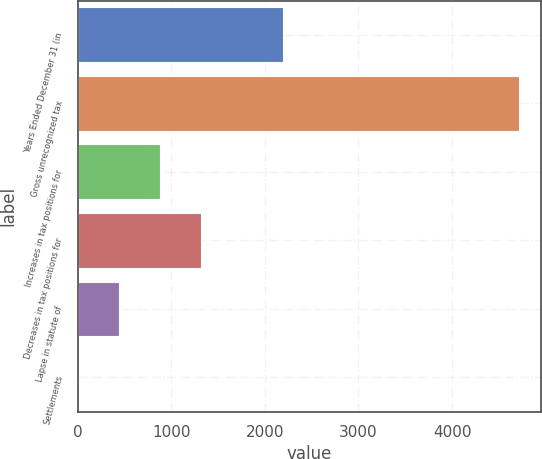<chart> <loc_0><loc_0><loc_500><loc_500><bar_chart><fcel>Years Ended December 31 (in<fcel>Gross unrecognized tax<fcel>Increases in tax positions for<fcel>Decreases in tax positions for<fcel>Lapse in statute of<fcel>Settlements<nl><fcel>2195<fcel>4717<fcel>881<fcel>1319<fcel>443<fcel>5<nl></chart> 